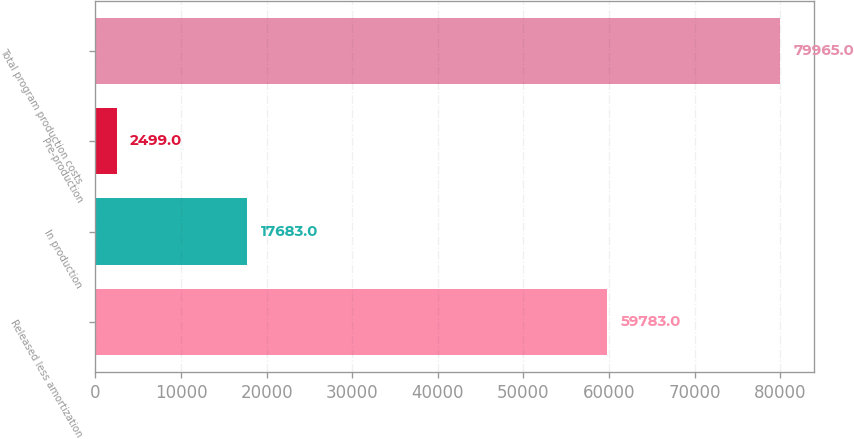Convert chart to OTSL. <chart><loc_0><loc_0><loc_500><loc_500><bar_chart><fcel>Released less amortization<fcel>In production<fcel>Pre-production<fcel>Total program production costs<nl><fcel>59783<fcel>17683<fcel>2499<fcel>79965<nl></chart> 